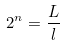<formula> <loc_0><loc_0><loc_500><loc_500>2 ^ { n } = \frac { L } { l }</formula> 